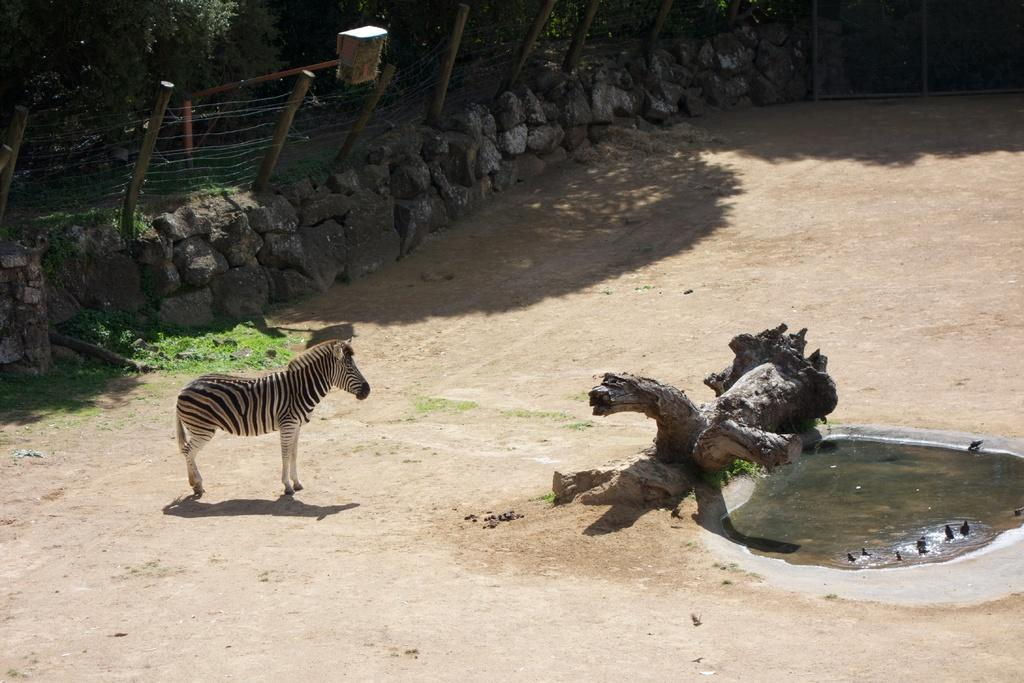What type of animal can be seen in the image? There is a Zebra in the image. What is visible on the trees in the image? Tree bark is visible in the image. What body of water is present in the image? There is a small water pond in the image. What type of barrier surrounds the water pond? A metal fence is present around the pond. What type of natural formation can be seen in the image? There are rocks in the image. What type of vegetation is present in the image? Trees are present in the image. What type of wildlife can be seen in the water? There are birds in the water. What type of fruit can be seen hanging from the trees in the image? There is no fruit visible in the image; only tree bark and trees are present. 